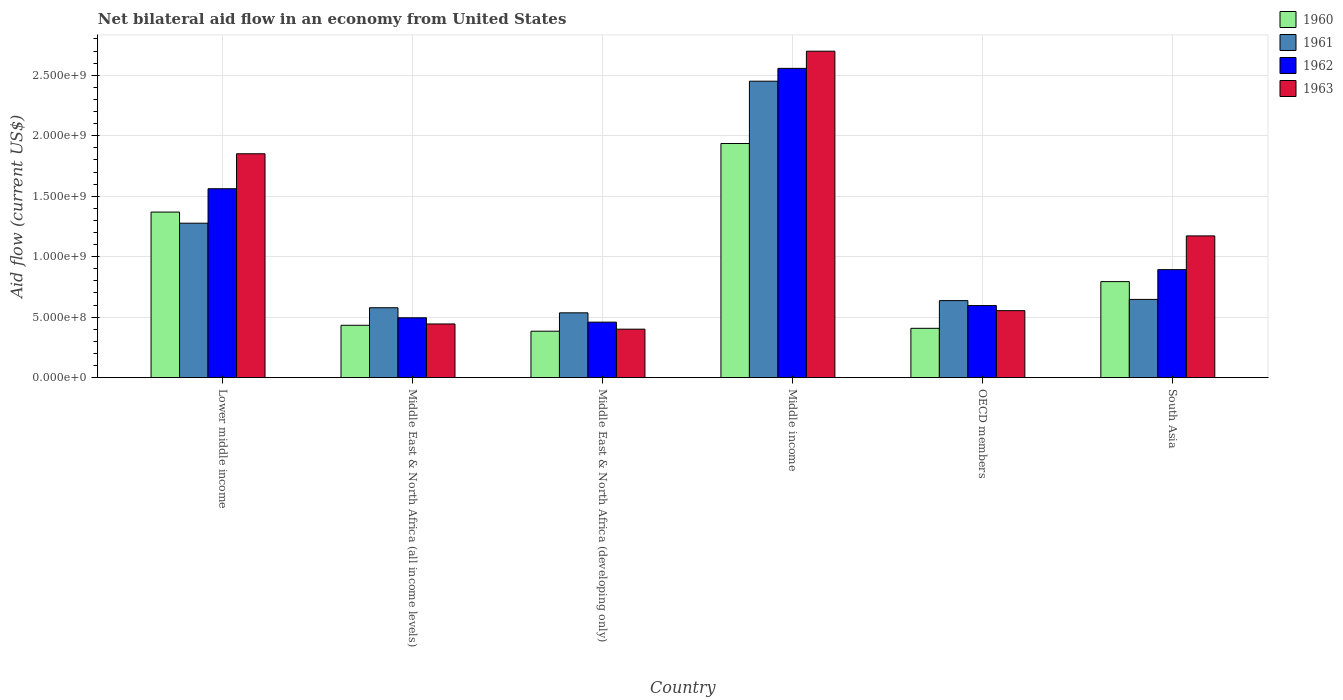How many groups of bars are there?
Provide a succinct answer. 6. Are the number of bars on each tick of the X-axis equal?
Your answer should be compact. Yes. What is the label of the 2nd group of bars from the left?
Make the answer very short. Middle East & North Africa (all income levels). What is the net bilateral aid flow in 1960 in South Asia?
Offer a terse response. 7.94e+08. Across all countries, what is the maximum net bilateral aid flow in 1960?
Offer a very short reply. 1.94e+09. Across all countries, what is the minimum net bilateral aid flow in 1963?
Make the answer very short. 4.01e+08. In which country was the net bilateral aid flow in 1961 minimum?
Your answer should be compact. Middle East & North Africa (developing only). What is the total net bilateral aid flow in 1960 in the graph?
Give a very brief answer. 5.32e+09. What is the difference between the net bilateral aid flow in 1960 in Middle East & North Africa (developing only) and that in South Asia?
Provide a succinct answer. -4.10e+08. What is the difference between the net bilateral aid flow in 1963 in Middle income and the net bilateral aid flow in 1960 in South Asia?
Your response must be concise. 1.90e+09. What is the average net bilateral aid flow in 1963 per country?
Provide a short and direct response. 1.19e+09. What is the difference between the net bilateral aid flow of/in 1962 and net bilateral aid flow of/in 1961 in Middle income?
Provide a short and direct response. 1.06e+08. What is the ratio of the net bilateral aid flow in 1960 in Middle income to that in OECD members?
Your answer should be compact. 4.75. Is the net bilateral aid flow in 1963 in Middle East & North Africa (all income levels) less than that in South Asia?
Your answer should be very brief. Yes. Is the difference between the net bilateral aid flow in 1962 in Middle East & North Africa (developing only) and Middle income greater than the difference between the net bilateral aid flow in 1961 in Middle East & North Africa (developing only) and Middle income?
Your answer should be very brief. No. What is the difference between the highest and the second highest net bilateral aid flow in 1960?
Make the answer very short. 5.67e+08. What is the difference between the highest and the lowest net bilateral aid flow in 1960?
Offer a very short reply. 1.55e+09. In how many countries, is the net bilateral aid flow in 1962 greater than the average net bilateral aid flow in 1962 taken over all countries?
Your answer should be compact. 2. Is it the case that in every country, the sum of the net bilateral aid flow in 1963 and net bilateral aid flow in 1960 is greater than the sum of net bilateral aid flow in 1961 and net bilateral aid flow in 1962?
Offer a terse response. No. What does the 1st bar from the left in South Asia represents?
Keep it short and to the point. 1960. What does the 1st bar from the right in Middle East & North Africa (all income levels) represents?
Keep it short and to the point. 1963. Is it the case that in every country, the sum of the net bilateral aid flow in 1961 and net bilateral aid flow in 1960 is greater than the net bilateral aid flow in 1962?
Your response must be concise. Yes. Are all the bars in the graph horizontal?
Make the answer very short. No. Does the graph contain any zero values?
Offer a very short reply. No. Does the graph contain grids?
Your answer should be compact. Yes. Where does the legend appear in the graph?
Your answer should be compact. Top right. How are the legend labels stacked?
Offer a very short reply. Vertical. What is the title of the graph?
Your response must be concise. Net bilateral aid flow in an economy from United States. What is the label or title of the X-axis?
Make the answer very short. Country. What is the label or title of the Y-axis?
Offer a terse response. Aid flow (current US$). What is the Aid flow (current US$) in 1960 in Lower middle income?
Keep it short and to the point. 1.37e+09. What is the Aid flow (current US$) in 1961 in Lower middle income?
Offer a terse response. 1.28e+09. What is the Aid flow (current US$) in 1962 in Lower middle income?
Ensure brevity in your answer.  1.56e+09. What is the Aid flow (current US$) in 1963 in Lower middle income?
Your response must be concise. 1.85e+09. What is the Aid flow (current US$) of 1960 in Middle East & North Africa (all income levels)?
Provide a succinct answer. 4.33e+08. What is the Aid flow (current US$) of 1961 in Middle East & North Africa (all income levels)?
Keep it short and to the point. 5.78e+08. What is the Aid flow (current US$) of 1962 in Middle East & North Africa (all income levels)?
Offer a terse response. 4.95e+08. What is the Aid flow (current US$) of 1963 in Middle East & North Africa (all income levels)?
Provide a succinct answer. 4.44e+08. What is the Aid flow (current US$) in 1960 in Middle East & North Africa (developing only)?
Provide a succinct answer. 3.84e+08. What is the Aid flow (current US$) of 1961 in Middle East & North Africa (developing only)?
Offer a terse response. 5.36e+08. What is the Aid flow (current US$) in 1962 in Middle East & North Africa (developing only)?
Provide a short and direct response. 4.59e+08. What is the Aid flow (current US$) of 1963 in Middle East & North Africa (developing only)?
Offer a terse response. 4.01e+08. What is the Aid flow (current US$) of 1960 in Middle income?
Your response must be concise. 1.94e+09. What is the Aid flow (current US$) of 1961 in Middle income?
Make the answer very short. 2.45e+09. What is the Aid flow (current US$) in 1962 in Middle income?
Make the answer very short. 2.56e+09. What is the Aid flow (current US$) in 1963 in Middle income?
Give a very brief answer. 2.70e+09. What is the Aid flow (current US$) of 1960 in OECD members?
Make the answer very short. 4.08e+08. What is the Aid flow (current US$) of 1961 in OECD members?
Give a very brief answer. 6.37e+08. What is the Aid flow (current US$) of 1962 in OECD members?
Offer a terse response. 5.96e+08. What is the Aid flow (current US$) in 1963 in OECD members?
Provide a succinct answer. 5.54e+08. What is the Aid flow (current US$) of 1960 in South Asia?
Provide a short and direct response. 7.94e+08. What is the Aid flow (current US$) of 1961 in South Asia?
Keep it short and to the point. 6.47e+08. What is the Aid flow (current US$) of 1962 in South Asia?
Keep it short and to the point. 8.93e+08. What is the Aid flow (current US$) in 1963 in South Asia?
Make the answer very short. 1.17e+09. Across all countries, what is the maximum Aid flow (current US$) in 1960?
Provide a short and direct response. 1.94e+09. Across all countries, what is the maximum Aid flow (current US$) of 1961?
Ensure brevity in your answer.  2.45e+09. Across all countries, what is the maximum Aid flow (current US$) of 1962?
Your answer should be very brief. 2.56e+09. Across all countries, what is the maximum Aid flow (current US$) in 1963?
Offer a terse response. 2.70e+09. Across all countries, what is the minimum Aid flow (current US$) in 1960?
Give a very brief answer. 3.84e+08. Across all countries, what is the minimum Aid flow (current US$) in 1961?
Ensure brevity in your answer.  5.36e+08. Across all countries, what is the minimum Aid flow (current US$) in 1962?
Offer a terse response. 4.59e+08. Across all countries, what is the minimum Aid flow (current US$) in 1963?
Keep it short and to the point. 4.01e+08. What is the total Aid flow (current US$) of 1960 in the graph?
Your response must be concise. 5.32e+09. What is the total Aid flow (current US$) of 1961 in the graph?
Offer a terse response. 6.13e+09. What is the total Aid flow (current US$) of 1962 in the graph?
Give a very brief answer. 6.56e+09. What is the total Aid flow (current US$) of 1963 in the graph?
Give a very brief answer. 7.12e+09. What is the difference between the Aid flow (current US$) of 1960 in Lower middle income and that in Middle East & North Africa (all income levels)?
Your answer should be very brief. 9.36e+08. What is the difference between the Aid flow (current US$) of 1961 in Lower middle income and that in Middle East & North Africa (all income levels)?
Your answer should be very brief. 6.99e+08. What is the difference between the Aid flow (current US$) of 1962 in Lower middle income and that in Middle East & North Africa (all income levels)?
Make the answer very short. 1.07e+09. What is the difference between the Aid flow (current US$) of 1963 in Lower middle income and that in Middle East & North Africa (all income levels)?
Give a very brief answer. 1.41e+09. What is the difference between the Aid flow (current US$) in 1960 in Lower middle income and that in Middle East & North Africa (developing only)?
Offer a terse response. 9.85e+08. What is the difference between the Aid flow (current US$) of 1961 in Lower middle income and that in Middle East & North Africa (developing only)?
Provide a succinct answer. 7.41e+08. What is the difference between the Aid flow (current US$) in 1962 in Lower middle income and that in Middle East & North Africa (developing only)?
Offer a very short reply. 1.10e+09. What is the difference between the Aid flow (current US$) in 1963 in Lower middle income and that in Middle East & North Africa (developing only)?
Make the answer very short. 1.45e+09. What is the difference between the Aid flow (current US$) of 1960 in Lower middle income and that in Middle income?
Make the answer very short. -5.67e+08. What is the difference between the Aid flow (current US$) in 1961 in Lower middle income and that in Middle income?
Offer a terse response. -1.17e+09. What is the difference between the Aid flow (current US$) of 1962 in Lower middle income and that in Middle income?
Your answer should be compact. -9.95e+08. What is the difference between the Aid flow (current US$) in 1963 in Lower middle income and that in Middle income?
Your answer should be compact. -8.48e+08. What is the difference between the Aid flow (current US$) in 1960 in Lower middle income and that in OECD members?
Your response must be concise. 9.61e+08. What is the difference between the Aid flow (current US$) in 1961 in Lower middle income and that in OECD members?
Make the answer very short. 6.40e+08. What is the difference between the Aid flow (current US$) in 1962 in Lower middle income and that in OECD members?
Ensure brevity in your answer.  9.66e+08. What is the difference between the Aid flow (current US$) of 1963 in Lower middle income and that in OECD members?
Ensure brevity in your answer.  1.30e+09. What is the difference between the Aid flow (current US$) in 1960 in Lower middle income and that in South Asia?
Provide a short and direct response. 5.75e+08. What is the difference between the Aid flow (current US$) of 1961 in Lower middle income and that in South Asia?
Offer a terse response. 6.30e+08. What is the difference between the Aid flow (current US$) of 1962 in Lower middle income and that in South Asia?
Your answer should be very brief. 6.69e+08. What is the difference between the Aid flow (current US$) of 1963 in Lower middle income and that in South Asia?
Give a very brief answer. 6.79e+08. What is the difference between the Aid flow (current US$) of 1960 in Middle East & North Africa (all income levels) and that in Middle East & North Africa (developing only)?
Offer a terse response. 4.90e+07. What is the difference between the Aid flow (current US$) in 1961 in Middle East & North Africa (all income levels) and that in Middle East & North Africa (developing only)?
Ensure brevity in your answer.  4.20e+07. What is the difference between the Aid flow (current US$) of 1962 in Middle East & North Africa (all income levels) and that in Middle East & North Africa (developing only)?
Your response must be concise. 3.60e+07. What is the difference between the Aid flow (current US$) in 1963 in Middle East & North Africa (all income levels) and that in Middle East & North Africa (developing only)?
Offer a terse response. 4.30e+07. What is the difference between the Aid flow (current US$) of 1960 in Middle East & North Africa (all income levels) and that in Middle income?
Offer a terse response. -1.50e+09. What is the difference between the Aid flow (current US$) of 1961 in Middle East & North Africa (all income levels) and that in Middle income?
Your answer should be compact. -1.87e+09. What is the difference between the Aid flow (current US$) of 1962 in Middle East & North Africa (all income levels) and that in Middle income?
Make the answer very short. -2.06e+09. What is the difference between the Aid flow (current US$) of 1963 in Middle East & North Africa (all income levels) and that in Middle income?
Offer a terse response. -2.26e+09. What is the difference between the Aid flow (current US$) in 1960 in Middle East & North Africa (all income levels) and that in OECD members?
Keep it short and to the point. 2.50e+07. What is the difference between the Aid flow (current US$) of 1961 in Middle East & North Africa (all income levels) and that in OECD members?
Your answer should be compact. -5.90e+07. What is the difference between the Aid flow (current US$) in 1962 in Middle East & North Africa (all income levels) and that in OECD members?
Your answer should be compact. -1.01e+08. What is the difference between the Aid flow (current US$) in 1963 in Middle East & North Africa (all income levels) and that in OECD members?
Your answer should be very brief. -1.10e+08. What is the difference between the Aid flow (current US$) of 1960 in Middle East & North Africa (all income levels) and that in South Asia?
Provide a succinct answer. -3.61e+08. What is the difference between the Aid flow (current US$) of 1961 in Middle East & North Africa (all income levels) and that in South Asia?
Keep it short and to the point. -6.90e+07. What is the difference between the Aid flow (current US$) in 1962 in Middle East & North Africa (all income levels) and that in South Asia?
Your answer should be very brief. -3.98e+08. What is the difference between the Aid flow (current US$) in 1963 in Middle East & North Africa (all income levels) and that in South Asia?
Keep it short and to the point. -7.28e+08. What is the difference between the Aid flow (current US$) of 1960 in Middle East & North Africa (developing only) and that in Middle income?
Your answer should be compact. -1.55e+09. What is the difference between the Aid flow (current US$) in 1961 in Middle East & North Africa (developing only) and that in Middle income?
Offer a very short reply. -1.92e+09. What is the difference between the Aid flow (current US$) of 1962 in Middle East & North Africa (developing only) and that in Middle income?
Provide a short and direct response. -2.10e+09. What is the difference between the Aid flow (current US$) of 1963 in Middle East & North Africa (developing only) and that in Middle income?
Give a very brief answer. -2.30e+09. What is the difference between the Aid flow (current US$) in 1960 in Middle East & North Africa (developing only) and that in OECD members?
Your answer should be compact. -2.40e+07. What is the difference between the Aid flow (current US$) of 1961 in Middle East & North Africa (developing only) and that in OECD members?
Give a very brief answer. -1.01e+08. What is the difference between the Aid flow (current US$) of 1962 in Middle East & North Africa (developing only) and that in OECD members?
Provide a short and direct response. -1.37e+08. What is the difference between the Aid flow (current US$) in 1963 in Middle East & North Africa (developing only) and that in OECD members?
Your answer should be compact. -1.53e+08. What is the difference between the Aid flow (current US$) in 1960 in Middle East & North Africa (developing only) and that in South Asia?
Your answer should be very brief. -4.10e+08. What is the difference between the Aid flow (current US$) in 1961 in Middle East & North Africa (developing only) and that in South Asia?
Your response must be concise. -1.11e+08. What is the difference between the Aid flow (current US$) of 1962 in Middle East & North Africa (developing only) and that in South Asia?
Provide a succinct answer. -4.34e+08. What is the difference between the Aid flow (current US$) of 1963 in Middle East & North Africa (developing only) and that in South Asia?
Your response must be concise. -7.71e+08. What is the difference between the Aid flow (current US$) of 1960 in Middle income and that in OECD members?
Offer a very short reply. 1.53e+09. What is the difference between the Aid flow (current US$) in 1961 in Middle income and that in OECD members?
Provide a short and direct response. 1.81e+09. What is the difference between the Aid flow (current US$) of 1962 in Middle income and that in OECD members?
Ensure brevity in your answer.  1.96e+09. What is the difference between the Aid flow (current US$) in 1963 in Middle income and that in OECD members?
Offer a terse response. 2.14e+09. What is the difference between the Aid flow (current US$) of 1960 in Middle income and that in South Asia?
Ensure brevity in your answer.  1.14e+09. What is the difference between the Aid flow (current US$) in 1961 in Middle income and that in South Asia?
Offer a terse response. 1.80e+09. What is the difference between the Aid flow (current US$) of 1962 in Middle income and that in South Asia?
Ensure brevity in your answer.  1.66e+09. What is the difference between the Aid flow (current US$) of 1963 in Middle income and that in South Asia?
Give a very brief answer. 1.53e+09. What is the difference between the Aid flow (current US$) in 1960 in OECD members and that in South Asia?
Your response must be concise. -3.86e+08. What is the difference between the Aid flow (current US$) of 1961 in OECD members and that in South Asia?
Give a very brief answer. -1.00e+07. What is the difference between the Aid flow (current US$) in 1962 in OECD members and that in South Asia?
Provide a short and direct response. -2.97e+08. What is the difference between the Aid flow (current US$) in 1963 in OECD members and that in South Asia?
Give a very brief answer. -6.18e+08. What is the difference between the Aid flow (current US$) in 1960 in Lower middle income and the Aid flow (current US$) in 1961 in Middle East & North Africa (all income levels)?
Keep it short and to the point. 7.91e+08. What is the difference between the Aid flow (current US$) in 1960 in Lower middle income and the Aid flow (current US$) in 1962 in Middle East & North Africa (all income levels)?
Keep it short and to the point. 8.74e+08. What is the difference between the Aid flow (current US$) in 1960 in Lower middle income and the Aid flow (current US$) in 1963 in Middle East & North Africa (all income levels)?
Your response must be concise. 9.25e+08. What is the difference between the Aid flow (current US$) of 1961 in Lower middle income and the Aid flow (current US$) of 1962 in Middle East & North Africa (all income levels)?
Your response must be concise. 7.82e+08. What is the difference between the Aid flow (current US$) of 1961 in Lower middle income and the Aid flow (current US$) of 1963 in Middle East & North Africa (all income levels)?
Ensure brevity in your answer.  8.33e+08. What is the difference between the Aid flow (current US$) in 1962 in Lower middle income and the Aid flow (current US$) in 1963 in Middle East & North Africa (all income levels)?
Your response must be concise. 1.12e+09. What is the difference between the Aid flow (current US$) of 1960 in Lower middle income and the Aid flow (current US$) of 1961 in Middle East & North Africa (developing only)?
Provide a short and direct response. 8.33e+08. What is the difference between the Aid flow (current US$) in 1960 in Lower middle income and the Aid flow (current US$) in 1962 in Middle East & North Africa (developing only)?
Your response must be concise. 9.10e+08. What is the difference between the Aid flow (current US$) of 1960 in Lower middle income and the Aid flow (current US$) of 1963 in Middle East & North Africa (developing only)?
Ensure brevity in your answer.  9.68e+08. What is the difference between the Aid flow (current US$) in 1961 in Lower middle income and the Aid flow (current US$) in 1962 in Middle East & North Africa (developing only)?
Ensure brevity in your answer.  8.18e+08. What is the difference between the Aid flow (current US$) of 1961 in Lower middle income and the Aid flow (current US$) of 1963 in Middle East & North Africa (developing only)?
Provide a short and direct response. 8.76e+08. What is the difference between the Aid flow (current US$) in 1962 in Lower middle income and the Aid flow (current US$) in 1963 in Middle East & North Africa (developing only)?
Make the answer very short. 1.16e+09. What is the difference between the Aid flow (current US$) in 1960 in Lower middle income and the Aid flow (current US$) in 1961 in Middle income?
Your answer should be very brief. -1.08e+09. What is the difference between the Aid flow (current US$) of 1960 in Lower middle income and the Aid flow (current US$) of 1962 in Middle income?
Your response must be concise. -1.19e+09. What is the difference between the Aid flow (current US$) in 1960 in Lower middle income and the Aid flow (current US$) in 1963 in Middle income?
Offer a terse response. -1.33e+09. What is the difference between the Aid flow (current US$) in 1961 in Lower middle income and the Aid flow (current US$) in 1962 in Middle income?
Your answer should be very brief. -1.28e+09. What is the difference between the Aid flow (current US$) of 1961 in Lower middle income and the Aid flow (current US$) of 1963 in Middle income?
Your answer should be compact. -1.42e+09. What is the difference between the Aid flow (current US$) of 1962 in Lower middle income and the Aid flow (current US$) of 1963 in Middle income?
Provide a succinct answer. -1.14e+09. What is the difference between the Aid flow (current US$) in 1960 in Lower middle income and the Aid flow (current US$) in 1961 in OECD members?
Provide a short and direct response. 7.32e+08. What is the difference between the Aid flow (current US$) of 1960 in Lower middle income and the Aid flow (current US$) of 1962 in OECD members?
Your response must be concise. 7.73e+08. What is the difference between the Aid flow (current US$) of 1960 in Lower middle income and the Aid flow (current US$) of 1963 in OECD members?
Offer a terse response. 8.15e+08. What is the difference between the Aid flow (current US$) of 1961 in Lower middle income and the Aid flow (current US$) of 1962 in OECD members?
Provide a short and direct response. 6.81e+08. What is the difference between the Aid flow (current US$) in 1961 in Lower middle income and the Aid flow (current US$) in 1963 in OECD members?
Keep it short and to the point. 7.23e+08. What is the difference between the Aid flow (current US$) of 1962 in Lower middle income and the Aid flow (current US$) of 1963 in OECD members?
Your response must be concise. 1.01e+09. What is the difference between the Aid flow (current US$) in 1960 in Lower middle income and the Aid flow (current US$) in 1961 in South Asia?
Your response must be concise. 7.22e+08. What is the difference between the Aid flow (current US$) in 1960 in Lower middle income and the Aid flow (current US$) in 1962 in South Asia?
Provide a succinct answer. 4.76e+08. What is the difference between the Aid flow (current US$) in 1960 in Lower middle income and the Aid flow (current US$) in 1963 in South Asia?
Your answer should be very brief. 1.97e+08. What is the difference between the Aid flow (current US$) of 1961 in Lower middle income and the Aid flow (current US$) of 1962 in South Asia?
Offer a terse response. 3.84e+08. What is the difference between the Aid flow (current US$) in 1961 in Lower middle income and the Aid flow (current US$) in 1963 in South Asia?
Make the answer very short. 1.05e+08. What is the difference between the Aid flow (current US$) of 1962 in Lower middle income and the Aid flow (current US$) of 1963 in South Asia?
Provide a succinct answer. 3.90e+08. What is the difference between the Aid flow (current US$) in 1960 in Middle East & North Africa (all income levels) and the Aid flow (current US$) in 1961 in Middle East & North Africa (developing only)?
Provide a short and direct response. -1.03e+08. What is the difference between the Aid flow (current US$) of 1960 in Middle East & North Africa (all income levels) and the Aid flow (current US$) of 1962 in Middle East & North Africa (developing only)?
Provide a short and direct response. -2.60e+07. What is the difference between the Aid flow (current US$) of 1960 in Middle East & North Africa (all income levels) and the Aid flow (current US$) of 1963 in Middle East & North Africa (developing only)?
Offer a very short reply. 3.20e+07. What is the difference between the Aid flow (current US$) in 1961 in Middle East & North Africa (all income levels) and the Aid flow (current US$) in 1962 in Middle East & North Africa (developing only)?
Your response must be concise. 1.19e+08. What is the difference between the Aid flow (current US$) in 1961 in Middle East & North Africa (all income levels) and the Aid flow (current US$) in 1963 in Middle East & North Africa (developing only)?
Your answer should be compact. 1.77e+08. What is the difference between the Aid flow (current US$) in 1962 in Middle East & North Africa (all income levels) and the Aid flow (current US$) in 1963 in Middle East & North Africa (developing only)?
Offer a very short reply. 9.40e+07. What is the difference between the Aid flow (current US$) in 1960 in Middle East & North Africa (all income levels) and the Aid flow (current US$) in 1961 in Middle income?
Make the answer very short. -2.02e+09. What is the difference between the Aid flow (current US$) of 1960 in Middle East & North Africa (all income levels) and the Aid flow (current US$) of 1962 in Middle income?
Your answer should be compact. -2.12e+09. What is the difference between the Aid flow (current US$) of 1960 in Middle East & North Africa (all income levels) and the Aid flow (current US$) of 1963 in Middle income?
Your response must be concise. -2.27e+09. What is the difference between the Aid flow (current US$) of 1961 in Middle East & North Africa (all income levels) and the Aid flow (current US$) of 1962 in Middle income?
Offer a terse response. -1.98e+09. What is the difference between the Aid flow (current US$) in 1961 in Middle East & North Africa (all income levels) and the Aid flow (current US$) in 1963 in Middle income?
Your answer should be very brief. -2.12e+09. What is the difference between the Aid flow (current US$) in 1962 in Middle East & North Africa (all income levels) and the Aid flow (current US$) in 1963 in Middle income?
Provide a short and direct response. -2.20e+09. What is the difference between the Aid flow (current US$) of 1960 in Middle East & North Africa (all income levels) and the Aid flow (current US$) of 1961 in OECD members?
Your answer should be compact. -2.04e+08. What is the difference between the Aid flow (current US$) in 1960 in Middle East & North Africa (all income levels) and the Aid flow (current US$) in 1962 in OECD members?
Offer a terse response. -1.63e+08. What is the difference between the Aid flow (current US$) of 1960 in Middle East & North Africa (all income levels) and the Aid flow (current US$) of 1963 in OECD members?
Make the answer very short. -1.21e+08. What is the difference between the Aid flow (current US$) in 1961 in Middle East & North Africa (all income levels) and the Aid flow (current US$) in 1962 in OECD members?
Your answer should be very brief. -1.80e+07. What is the difference between the Aid flow (current US$) in 1961 in Middle East & North Africa (all income levels) and the Aid flow (current US$) in 1963 in OECD members?
Make the answer very short. 2.40e+07. What is the difference between the Aid flow (current US$) of 1962 in Middle East & North Africa (all income levels) and the Aid flow (current US$) of 1963 in OECD members?
Ensure brevity in your answer.  -5.90e+07. What is the difference between the Aid flow (current US$) of 1960 in Middle East & North Africa (all income levels) and the Aid flow (current US$) of 1961 in South Asia?
Your answer should be very brief. -2.14e+08. What is the difference between the Aid flow (current US$) of 1960 in Middle East & North Africa (all income levels) and the Aid flow (current US$) of 1962 in South Asia?
Your response must be concise. -4.60e+08. What is the difference between the Aid flow (current US$) of 1960 in Middle East & North Africa (all income levels) and the Aid flow (current US$) of 1963 in South Asia?
Provide a short and direct response. -7.39e+08. What is the difference between the Aid flow (current US$) in 1961 in Middle East & North Africa (all income levels) and the Aid flow (current US$) in 1962 in South Asia?
Your answer should be very brief. -3.15e+08. What is the difference between the Aid flow (current US$) of 1961 in Middle East & North Africa (all income levels) and the Aid flow (current US$) of 1963 in South Asia?
Offer a terse response. -5.94e+08. What is the difference between the Aid flow (current US$) in 1962 in Middle East & North Africa (all income levels) and the Aid flow (current US$) in 1963 in South Asia?
Give a very brief answer. -6.77e+08. What is the difference between the Aid flow (current US$) in 1960 in Middle East & North Africa (developing only) and the Aid flow (current US$) in 1961 in Middle income?
Provide a short and direct response. -2.07e+09. What is the difference between the Aid flow (current US$) in 1960 in Middle East & North Africa (developing only) and the Aid flow (current US$) in 1962 in Middle income?
Make the answer very short. -2.17e+09. What is the difference between the Aid flow (current US$) in 1960 in Middle East & North Africa (developing only) and the Aid flow (current US$) in 1963 in Middle income?
Provide a short and direct response. -2.32e+09. What is the difference between the Aid flow (current US$) of 1961 in Middle East & North Africa (developing only) and the Aid flow (current US$) of 1962 in Middle income?
Ensure brevity in your answer.  -2.02e+09. What is the difference between the Aid flow (current US$) of 1961 in Middle East & North Africa (developing only) and the Aid flow (current US$) of 1963 in Middle income?
Ensure brevity in your answer.  -2.16e+09. What is the difference between the Aid flow (current US$) in 1962 in Middle East & North Africa (developing only) and the Aid flow (current US$) in 1963 in Middle income?
Ensure brevity in your answer.  -2.24e+09. What is the difference between the Aid flow (current US$) in 1960 in Middle East & North Africa (developing only) and the Aid flow (current US$) in 1961 in OECD members?
Provide a short and direct response. -2.53e+08. What is the difference between the Aid flow (current US$) in 1960 in Middle East & North Africa (developing only) and the Aid flow (current US$) in 1962 in OECD members?
Provide a short and direct response. -2.12e+08. What is the difference between the Aid flow (current US$) of 1960 in Middle East & North Africa (developing only) and the Aid flow (current US$) of 1963 in OECD members?
Offer a very short reply. -1.70e+08. What is the difference between the Aid flow (current US$) of 1961 in Middle East & North Africa (developing only) and the Aid flow (current US$) of 1962 in OECD members?
Your answer should be very brief. -6.00e+07. What is the difference between the Aid flow (current US$) in 1961 in Middle East & North Africa (developing only) and the Aid flow (current US$) in 1963 in OECD members?
Your answer should be compact. -1.80e+07. What is the difference between the Aid flow (current US$) in 1962 in Middle East & North Africa (developing only) and the Aid flow (current US$) in 1963 in OECD members?
Your response must be concise. -9.50e+07. What is the difference between the Aid flow (current US$) of 1960 in Middle East & North Africa (developing only) and the Aid flow (current US$) of 1961 in South Asia?
Offer a terse response. -2.63e+08. What is the difference between the Aid flow (current US$) in 1960 in Middle East & North Africa (developing only) and the Aid flow (current US$) in 1962 in South Asia?
Offer a very short reply. -5.09e+08. What is the difference between the Aid flow (current US$) in 1960 in Middle East & North Africa (developing only) and the Aid flow (current US$) in 1963 in South Asia?
Offer a terse response. -7.88e+08. What is the difference between the Aid flow (current US$) in 1961 in Middle East & North Africa (developing only) and the Aid flow (current US$) in 1962 in South Asia?
Your answer should be compact. -3.57e+08. What is the difference between the Aid flow (current US$) of 1961 in Middle East & North Africa (developing only) and the Aid flow (current US$) of 1963 in South Asia?
Offer a terse response. -6.36e+08. What is the difference between the Aid flow (current US$) of 1962 in Middle East & North Africa (developing only) and the Aid flow (current US$) of 1963 in South Asia?
Make the answer very short. -7.13e+08. What is the difference between the Aid flow (current US$) of 1960 in Middle income and the Aid flow (current US$) of 1961 in OECD members?
Your response must be concise. 1.30e+09. What is the difference between the Aid flow (current US$) of 1960 in Middle income and the Aid flow (current US$) of 1962 in OECD members?
Make the answer very short. 1.34e+09. What is the difference between the Aid flow (current US$) of 1960 in Middle income and the Aid flow (current US$) of 1963 in OECD members?
Your answer should be compact. 1.38e+09. What is the difference between the Aid flow (current US$) in 1961 in Middle income and the Aid flow (current US$) in 1962 in OECD members?
Provide a short and direct response. 1.86e+09. What is the difference between the Aid flow (current US$) in 1961 in Middle income and the Aid flow (current US$) in 1963 in OECD members?
Provide a succinct answer. 1.90e+09. What is the difference between the Aid flow (current US$) of 1962 in Middle income and the Aid flow (current US$) of 1963 in OECD members?
Your response must be concise. 2.00e+09. What is the difference between the Aid flow (current US$) of 1960 in Middle income and the Aid flow (current US$) of 1961 in South Asia?
Your answer should be very brief. 1.29e+09. What is the difference between the Aid flow (current US$) in 1960 in Middle income and the Aid flow (current US$) in 1962 in South Asia?
Offer a terse response. 1.04e+09. What is the difference between the Aid flow (current US$) in 1960 in Middle income and the Aid flow (current US$) in 1963 in South Asia?
Give a very brief answer. 7.64e+08. What is the difference between the Aid flow (current US$) in 1961 in Middle income and the Aid flow (current US$) in 1962 in South Asia?
Provide a succinct answer. 1.56e+09. What is the difference between the Aid flow (current US$) in 1961 in Middle income and the Aid flow (current US$) in 1963 in South Asia?
Make the answer very short. 1.28e+09. What is the difference between the Aid flow (current US$) of 1962 in Middle income and the Aid flow (current US$) of 1963 in South Asia?
Offer a terse response. 1.38e+09. What is the difference between the Aid flow (current US$) in 1960 in OECD members and the Aid flow (current US$) in 1961 in South Asia?
Your response must be concise. -2.39e+08. What is the difference between the Aid flow (current US$) in 1960 in OECD members and the Aid flow (current US$) in 1962 in South Asia?
Your answer should be very brief. -4.85e+08. What is the difference between the Aid flow (current US$) of 1960 in OECD members and the Aid flow (current US$) of 1963 in South Asia?
Offer a terse response. -7.64e+08. What is the difference between the Aid flow (current US$) in 1961 in OECD members and the Aid flow (current US$) in 1962 in South Asia?
Offer a very short reply. -2.56e+08. What is the difference between the Aid flow (current US$) in 1961 in OECD members and the Aid flow (current US$) in 1963 in South Asia?
Your answer should be very brief. -5.35e+08. What is the difference between the Aid flow (current US$) in 1962 in OECD members and the Aid flow (current US$) in 1963 in South Asia?
Keep it short and to the point. -5.76e+08. What is the average Aid flow (current US$) in 1960 per country?
Give a very brief answer. 8.87e+08. What is the average Aid flow (current US$) of 1961 per country?
Make the answer very short. 1.02e+09. What is the average Aid flow (current US$) of 1962 per country?
Provide a short and direct response. 1.09e+09. What is the average Aid flow (current US$) of 1963 per country?
Give a very brief answer. 1.19e+09. What is the difference between the Aid flow (current US$) in 1960 and Aid flow (current US$) in 1961 in Lower middle income?
Offer a terse response. 9.20e+07. What is the difference between the Aid flow (current US$) in 1960 and Aid flow (current US$) in 1962 in Lower middle income?
Keep it short and to the point. -1.93e+08. What is the difference between the Aid flow (current US$) of 1960 and Aid flow (current US$) of 1963 in Lower middle income?
Your response must be concise. -4.82e+08. What is the difference between the Aid flow (current US$) of 1961 and Aid flow (current US$) of 1962 in Lower middle income?
Provide a succinct answer. -2.85e+08. What is the difference between the Aid flow (current US$) of 1961 and Aid flow (current US$) of 1963 in Lower middle income?
Give a very brief answer. -5.74e+08. What is the difference between the Aid flow (current US$) in 1962 and Aid flow (current US$) in 1963 in Lower middle income?
Provide a succinct answer. -2.89e+08. What is the difference between the Aid flow (current US$) of 1960 and Aid flow (current US$) of 1961 in Middle East & North Africa (all income levels)?
Ensure brevity in your answer.  -1.45e+08. What is the difference between the Aid flow (current US$) of 1960 and Aid flow (current US$) of 1962 in Middle East & North Africa (all income levels)?
Your answer should be compact. -6.20e+07. What is the difference between the Aid flow (current US$) in 1960 and Aid flow (current US$) in 1963 in Middle East & North Africa (all income levels)?
Ensure brevity in your answer.  -1.10e+07. What is the difference between the Aid flow (current US$) in 1961 and Aid flow (current US$) in 1962 in Middle East & North Africa (all income levels)?
Your response must be concise. 8.30e+07. What is the difference between the Aid flow (current US$) of 1961 and Aid flow (current US$) of 1963 in Middle East & North Africa (all income levels)?
Keep it short and to the point. 1.34e+08. What is the difference between the Aid flow (current US$) of 1962 and Aid flow (current US$) of 1963 in Middle East & North Africa (all income levels)?
Offer a very short reply. 5.10e+07. What is the difference between the Aid flow (current US$) of 1960 and Aid flow (current US$) of 1961 in Middle East & North Africa (developing only)?
Provide a short and direct response. -1.52e+08. What is the difference between the Aid flow (current US$) of 1960 and Aid flow (current US$) of 1962 in Middle East & North Africa (developing only)?
Keep it short and to the point. -7.50e+07. What is the difference between the Aid flow (current US$) in 1960 and Aid flow (current US$) in 1963 in Middle East & North Africa (developing only)?
Offer a very short reply. -1.70e+07. What is the difference between the Aid flow (current US$) of 1961 and Aid flow (current US$) of 1962 in Middle East & North Africa (developing only)?
Your response must be concise. 7.70e+07. What is the difference between the Aid flow (current US$) in 1961 and Aid flow (current US$) in 1963 in Middle East & North Africa (developing only)?
Your response must be concise. 1.35e+08. What is the difference between the Aid flow (current US$) in 1962 and Aid flow (current US$) in 1963 in Middle East & North Africa (developing only)?
Your response must be concise. 5.80e+07. What is the difference between the Aid flow (current US$) of 1960 and Aid flow (current US$) of 1961 in Middle income?
Ensure brevity in your answer.  -5.15e+08. What is the difference between the Aid flow (current US$) of 1960 and Aid flow (current US$) of 1962 in Middle income?
Your response must be concise. -6.21e+08. What is the difference between the Aid flow (current US$) of 1960 and Aid flow (current US$) of 1963 in Middle income?
Offer a terse response. -7.63e+08. What is the difference between the Aid flow (current US$) in 1961 and Aid flow (current US$) in 1962 in Middle income?
Your response must be concise. -1.06e+08. What is the difference between the Aid flow (current US$) in 1961 and Aid flow (current US$) in 1963 in Middle income?
Your answer should be compact. -2.48e+08. What is the difference between the Aid flow (current US$) of 1962 and Aid flow (current US$) of 1963 in Middle income?
Your answer should be very brief. -1.42e+08. What is the difference between the Aid flow (current US$) in 1960 and Aid flow (current US$) in 1961 in OECD members?
Offer a terse response. -2.29e+08. What is the difference between the Aid flow (current US$) of 1960 and Aid flow (current US$) of 1962 in OECD members?
Give a very brief answer. -1.88e+08. What is the difference between the Aid flow (current US$) in 1960 and Aid flow (current US$) in 1963 in OECD members?
Give a very brief answer. -1.46e+08. What is the difference between the Aid flow (current US$) in 1961 and Aid flow (current US$) in 1962 in OECD members?
Your answer should be compact. 4.10e+07. What is the difference between the Aid flow (current US$) in 1961 and Aid flow (current US$) in 1963 in OECD members?
Ensure brevity in your answer.  8.30e+07. What is the difference between the Aid flow (current US$) of 1962 and Aid flow (current US$) of 1963 in OECD members?
Your answer should be compact. 4.20e+07. What is the difference between the Aid flow (current US$) of 1960 and Aid flow (current US$) of 1961 in South Asia?
Provide a short and direct response. 1.47e+08. What is the difference between the Aid flow (current US$) in 1960 and Aid flow (current US$) in 1962 in South Asia?
Ensure brevity in your answer.  -9.90e+07. What is the difference between the Aid flow (current US$) of 1960 and Aid flow (current US$) of 1963 in South Asia?
Give a very brief answer. -3.78e+08. What is the difference between the Aid flow (current US$) in 1961 and Aid flow (current US$) in 1962 in South Asia?
Your response must be concise. -2.46e+08. What is the difference between the Aid flow (current US$) in 1961 and Aid flow (current US$) in 1963 in South Asia?
Offer a very short reply. -5.25e+08. What is the difference between the Aid flow (current US$) of 1962 and Aid flow (current US$) of 1963 in South Asia?
Keep it short and to the point. -2.79e+08. What is the ratio of the Aid flow (current US$) in 1960 in Lower middle income to that in Middle East & North Africa (all income levels)?
Ensure brevity in your answer.  3.16. What is the ratio of the Aid flow (current US$) of 1961 in Lower middle income to that in Middle East & North Africa (all income levels)?
Keep it short and to the point. 2.21. What is the ratio of the Aid flow (current US$) in 1962 in Lower middle income to that in Middle East & North Africa (all income levels)?
Ensure brevity in your answer.  3.16. What is the ratio of the Aid flow (current US$) in 1963 in Lower middle income to that in Middle East & North Africa (all income levels)?
Ensure brevity in your answer.  4.17. What is the ratio of the Aid flow (current US$) in 1960 in Lower middle income to that in Middle East & North Africa (developing only)?
Your response must be concise. 3.57. What is the ratio of the Aid flow (current US$) in 1961 in Lower middle income to that in Middle East & North Africa (developing only)?
Ensure brevity in your answer.  2.38. What is the ratio of the Aid flow (current US$) of 1962 in Lower middle income to that in Middle East & North Africa (developing only)?
Your answer should be compact. 3.4. What is the ratio of the Aid flow (current US$) in 1963 in Lower middle income to that in Middle East & North Africa (developing only)?
Ensure brevity in your answer.  4.62. What is the ratio of the Aid flow (current US$) of 1960 in Lower middle income to that in Middle income?
Provide a succinct answer. 0.71. What is the ratio of the Aid flow (current US$) in 1961 in Lower middle income to that in Middle income?
Ensure brevity in your answer.  0.52. What is the ratio of the Aid flow (current US$) in 1962 in Lower middle income to that in Middle income?
Provide a short and direct response. 0.61. What is the ratio of the Aid flow (current US$) in 1963 in Lower middle income to that in Middle income?
Offer a very short reply. 0.69. What is the ratio of the Aid flow (current US$) of 1960 in Lower middle income to that in OECD members?
Keep it short and to the point. 3.36. What is the ratio of the Aid flow (current US$) in 1961 in Lower middle income to that in OECD members?
Your answer should be very brief. 2. What is the ratio of the Aid flow (current US$) of 1962 in Lower middle income to that in OECD members?
Keep it short and to the point. 2.62. What is the ratio of the Aid flow (current US$) in 1963 in Lower middle income to that in OECD members?
Give a very brief answer. 3.34. What is the ratio of the Aid flow (current US$) of 1960 in Lower middle income to that in South Asia?
Ensure brevity in your answer.  1.72. What is the ratio of the Aid flow (current US$) in 1961 in Lower middle income to that in South Asia?
Provide a succinct answer. 1.97. What is the ratio of the Aid flow (current US$) of 1962 in Lower middle income to that in South Asia?
Your answer should be very brief. 1.75. What is the ratio of the Aid flow (current US$) in 1963 in Lower middle income to that in South Asia?
Your answer should be compact. 1.58. What is the ratio of the Aid flow (current US$) in 1960 in Middle East & North Africa (all income levels) to that in Middle East & North Africa (developing only)?
Your response must be concise. 1.13. What is the ratio of the Aid flow (current US$) in 1961 in Middle East & North Africa (all income levels) to that in Middle East & North Africa (developing only)?
Make the answer very short. 1.08. What is the ratio of the Aid flow (current US$) in 1962 in Middle East & North Africa (all income levels) to that in Middle East & North Africa (developing only)?
Provide a short and direct response. 1.08. What is the ratio of the Aid flow (current US$) of 1963 in Middle East & North Africa (all income levels) to that in Middle East & North Africa (developing only)?
Ensure brevity in your answer.  1.11. What is the ratio of the Aid flow (current US$) of 1960 in Middle East & North Africa (all income levels) to that in Middle income?
Provide a short and direct response. 0.22. What is the ratio of the Aid flow (current US$) of 1961 in Middle East & North Africa (all income levels) to that in Middle income?
Your answer should be very brief. 0.24. What is the ratio of the Aid flow (current US$) in 1962 in Middle East & North Africa (all income levels) to that in Middle income?
Your response must be concise. 0.19. What is the ratio of the Aid flow (current US$) of 1963 in Middle East & North Africa (all income levels) to that in Middle income?
Provide a succinct answer. 0.16. What is the ratio of the Aid flow (current US$) of 1960 in Middle East & North Africa (all income levels) to that in OECD members?
Your answer should be compact. 1.06. What is the ratio of the Aid flow (current US$) of 1961 in Middle East & North Africa (all income levels) to that in OECD members?
Provide a short and direct response. 0.91. What is the ratio of the Aid flow (current US$) of 1962 in Middle East & North Africa (all income levels) to that in OECD members?
Your answer should be compact. 0.83. What is the ratio of the Aid flow (current US$) in 1963 in Middle East & North Africa (all income levels) to that in OECD members?
Give a very brief answer. 0.8. What is the ratio of the Aid flow (current US$) in 1960 in Middle East & North Africa (all income levels) to that in South Asia?
Provide a short and direct response. 0.55. What is the ratio of the Aid flow (current US$) of 1961 in Middle East & North Africa (all income levels) to that in South Asia?
Make the answer very short. 0.89. What is the ratio of the Aid flow (current US$) in 1962 in Middle East & North Africa (all income levels) to that in South Asia?
Offer a very short reply. 0.55. What is the ratio of the Aid flow (current US$) in 1963 in Middle East & North Africa (all income levels) to that in South Asia?
Offer a very short reply. 0.38. What is the ratio of the Aid flow (current US$) of 1960 in Middle East & North Africa (developing only) to that in Middle income?
Make the answer very short. 0.2. What is the ratio of the Aid flow (current US$) of 1961 in Middle East & North Africa (developing only) to that in Middle income?
Your answer should be compact. 0.22. What is the ratio of the Aid flow (current US$) in 1962 in Middle East & North Africa (developing only) to that in Middle income?
Offer a terse response. 0.18. What is the ratio of the Aid flow (current US$) of 1963 in Middle East & North Africa (developing only) to that in Middle income?
Keep it short and to the point. 0.15. What is the ratio of the Aid flow (current US$) in 1960 in Middle East & North Africa (developing only) to that in OECD members?
Your response must be concise. 0.94. What is the ratio of the Aid flow (current US$) in 1961 in Middle East & North Africa (developing only) to that in OECD members?
Provide a short and direct response. 0.84. What is the ratio of the Aid flow (current US$) of 1962 in Middle East & North Africa (developing only) to that in OECD members?
Give a very brief answer. 0.77. What is the ratio of the Aid flow (current US$) in 1963 in Middle East & North Africa (developing only) to that in OECD members?
Ensure brevity in your answer.  0.72. What is the ratio of the Aid flow (current US$) of 1960 in Middle East & North Africa (developing only) to that in South Asia?
Ensure brevity in your answer.  0.48. What is the ratio of the Aid flow (current US$) of 1961 in Middle East & North Africa (developing only) to that in South Asia?
Ensure brevity in your answer.  0.83. What is the ratio of the Aid flow (current US$) in 1962 in Middle East & North Africa (developing only) to that in South Asia?
Give a very brief answer. 0.51. What is the ratio of the Aid flow (current US$) of 1963 in Middle East & North Africa (developing only) to that in South Asia?
Provide a succinct answer. 0.34. What is the ratio of the Aid flow (current US$) of 1960 in Middle income to that in OECD members?
Provide a short and direct response. 4.75. What is the ratio of the Aid flow (current US$) of 1961 in Middle income to that in OECD members?
Give a very brief answer. 3.85. What is the ratio of the Aid flow (current US$) in 1962 in Middle income to that in OECD members?
Your response must be concise. 4.29. What is the ratio of the Aid flow (current US$) of 1963 in Middle income to that in OECD members?
Offer a terse response. 4.87. What is the ratio of the Aid flow (current US$) of 1960 in Middle income to that in South Asia?
Offer a terse response. 2.44. What is the ratio of the Aid flow (current US$) of 1961 in Middle income to that in South Asia?
Give a very brief answer. 3.79. What is the ratio of the Aid flow (current US$) of 1962 in Middle income to that in South Asia?
Provide a succinct answer. 2.86. What is the ratio of the Aid flow (current US$) in 1963 in Middle income to that in South Asia?
Offer a terse response. 2.3. What is the ratio of the Aid flow (current US$) in 1960 in OECD members to that in South Asia?
Keep it short and to the point. 0.51. What is the ratio of the Aid flow (current US$) of 1961 in OECD members to that in South Asia?
Offer a terse response. 0.98. What is the ratio of the Aid flow (current US$) of 1962 in OECD members to that in South Asia?
Ensure brevity in your answer.  0.67. What is the ratio of the Aid flow (current US$) of 1963 in OECD members to that in South Asia?
Provide a short and direct response. 0.47. What is the difference between the highest and the second highest Aid flow (current US$) in 1960?
Offer a very short reply. 5.67e+08. What is the difference between the highest and the second highest Aid flow (current US$) of 1961?
Your answer should be compact. 1.17e+09. What is the difference between the highest and the second highest Aid flow (current US$) of 1962?
Your answer should be compact. 9.95e+08. What is the difference between the highest and the second highest Aid flow (current US$) in 1963?
Give a very brief answer. 8.48e+08. What is the difference between the highest and the lowest Aid flow (current US$) in 1960?
Keep it short and to the point. 1.55e+09. What is the difference between the highest and the lowest Aid flow (current US$) of 1961?
Give a very brief answer. 1.92e+09. What is the difference between the highest and the lowest Aid flow (current US$) in 1962?
Offer a terse response. 2.10e+09. What is the difference between the highest and the lowest Aid flow (current US$) of 1963?
Provide a short and direct response. 2.30e+09. 